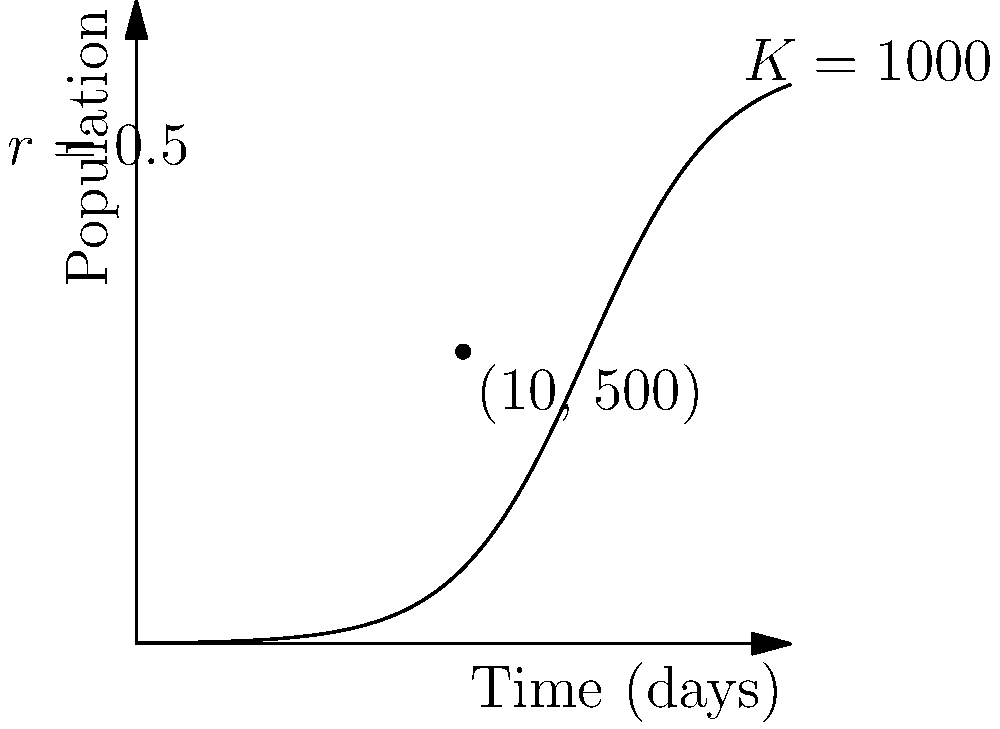Given the logistic growth curve for a disease spread in a population as shown in the figure, with a carrying capacity $K=1000$ and growth rate $r=0.5$, calculate the instantaneous rate of change in the infected population at day 10, when the infected population is 500. To solve this problem, we'll use the logistic growth equation and its derivative:

1) The logistic growth equation is:
   $$N(t) = \frac{K}{1 + (\frac{K}{N_0} - 1)e^{-rt}}$$

2) The derivative of this equation gives the rate of change:
   $$\frac{dN}{dt} = rN(1-\frac{N}{K})$$

3) We're given:
   $K = 1000$ (carrying capacity)
   $r = 0.5$ (growth rate)
   $N = 500$ (population at day 10)

4) Plugging these values into the derivative equation:
   $$\frac{dN}{dt} = 0.5 \cdot 500(1-\frac{500}{1000})$$

5) Simplify:
   $$\frac{dN}{dt} = 250(1-0.5) = 250(0.5) = 125$$

Therefore, the instantaneous rate of change at day 10 is 125 individuals per day.
Answer: 125 individuals/day 